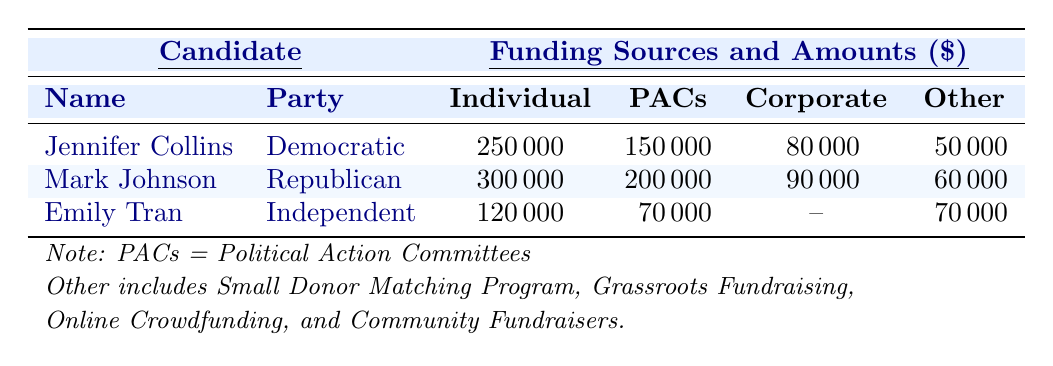What is the total amount raised by Mark Johnson from Individual Contributions? Mark Johnson has received 300000 from Individual Contributions as listed in the table.
Answer: 300000 What are the total funds raised by Jennifer Collins? To find the total funds raised by Jennifer Collins, we sum her contributions: 250000 (Individual) + 150000 (PACs) + 80000 (Corporate) + 50000 (Other) = 530000.
Answer: 530000 Is Emily Tran receiving any funds from Corporate Donations? The table indicates that Emily Tran's Corporate Donations amount is marked as {--}, indicating no funds received from this source.
Answer: No Which candidate has the highest amount from Political Action Committees? Mark Johnson has the highest amount from Political Action Committees, with a total of 200000, compared to Jennifer Collins and Emily Tran.
Answer: Mark Johnson What is the average amount raised from the 'Other' category across all candidates? The amounts in the 'Other' category are 50000 (Jennifer Collins), 60000 (Mark Johnson), and 70000 (Emily Tran). Adding these gives 50000 + 60000 + 70000 = 180000. Dividing by the number of candidates (3) gives an average of 180000 / 3 = 60000.
Answer: 60000 If we combine the funding sources of Jennifer Collins and Emily Tran, what is the total amount from Individual Contributions? Jennifer Collins has 250000 in Individual Contributions and Emily Tran has 120000. Summing these amounts gives 250000 + 120000 = 370000.
Answer: 370000 What percentage of Mark Johnson's total funding comes from Individual Contributions? Mark Johnson's total funding is 300000 (Individual) + 200000 (PACs) + 90000 (Corporate) + 60000 (Other) = 650000. The percentage from Individual Contributions is (300000 / 650000) * 100 = 46.15%.
Answer: 46.15% Which candidate relies the most on PAC funding compared to their total funding? Mark Johnson's total funding is 650000, with PAC funding of 200000. For Jennifer Collins, the total is 530000, with 150000 from PACs. The percentage for Mark is about (200000 / 650000) * 100 ≈ 30.77% and for Jennifer is (150000 / 530000) * 100 ≈ 28.30%. Therefore, Mark Johnson relies more on PAC funding comparatively.
Answer: Mark Johnson How much more does Mark Johnson receive in total from all sources compared to Emily Tran? Mark Johnson's total funding is 650000, and Emily Tran's total is 320000 (120000 + 70000 + 0 + 40000). The difference is 650000 - 320000 = 330000.
Answer: 330000 